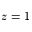<formula> <loc_0><loc_0><loc_500><loc_500>z = 1</formula> 